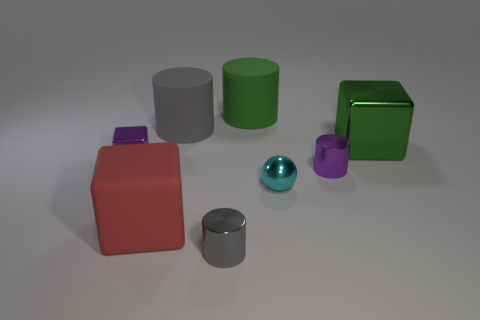Is there anything else of the same color as the large shiny object?
Provide a short and direct response. Yes. There is a cube that is behind the tiny purple object left of the large green rubber cylinder; how big is it?
Your answer should be very brief. Large. Does the red cube have the same size as the gray metal object that is in front of the tiny cyan object?
Ensure brevity in your answer.  No. There is a shiny cube that is the same size as the cyan object; what is its color?
Keep it short and to the point. Purple. How big is the green metallic thing?
Provide a short and direct response. Large. Is the big cylinder that is on the left side of the gray metallic cylinder made of the same material as the large red thing?
Offer a very short reply. Yes. Does the green shiny object have the same shape as the red rubber thing?
Make the answer very short. Yes. What shape is the matte thing in front of the metal block that is behind the tiny purple metallic object that is left of the tiny cyan thing?
Your answer should be very brief. Cube. Is the shape of the purple metal object on the right side of the large red block the same as the gray thing that is in front of the big metal thing?
Give a very brief answer. Yes. Is there a small cylinder that has the same material as the large green block?
Keep it short and to the point. Yes. 